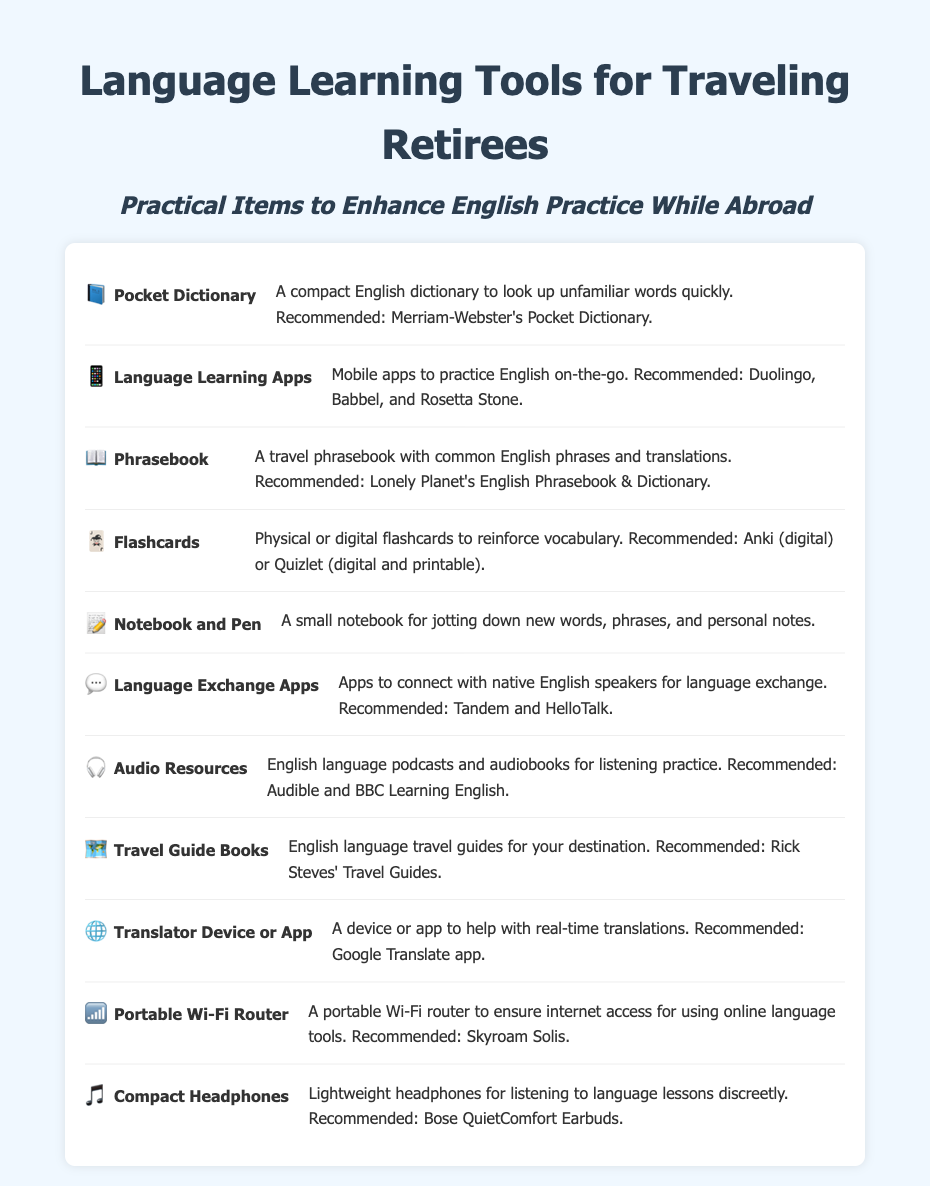What is a recommended pocket dictionary? The recommended pocket dictionary mentioned in the document is Merriam-Webster's Pocket Dictionary.
Answer: Merriam-Webster's Pocket Dictionary Which app is suggested for language learning? The document lists several language learning apps, with Duolingo being one of the recommended ones.
Answer: Duolingo What type of resource is recommended for English listening practice? The document recommends audio resources like podcasts and audiobooks for listening practice.
Answer: Audio resources What should you carry to improve vocabulary reinforcement? The document mentions flashcards as a tool to reinforce vocabulary.
Answer: Flashcards What is the purpose of a portable Wi-Fi router? The purpose of a portable Wi-Fi router is to ensure internet access for using online language tools.
Answer: Internet access Which device is recommended for real-time translations? The Google Translate app is recommended for real-time translations.
Answer: Google Translate app 